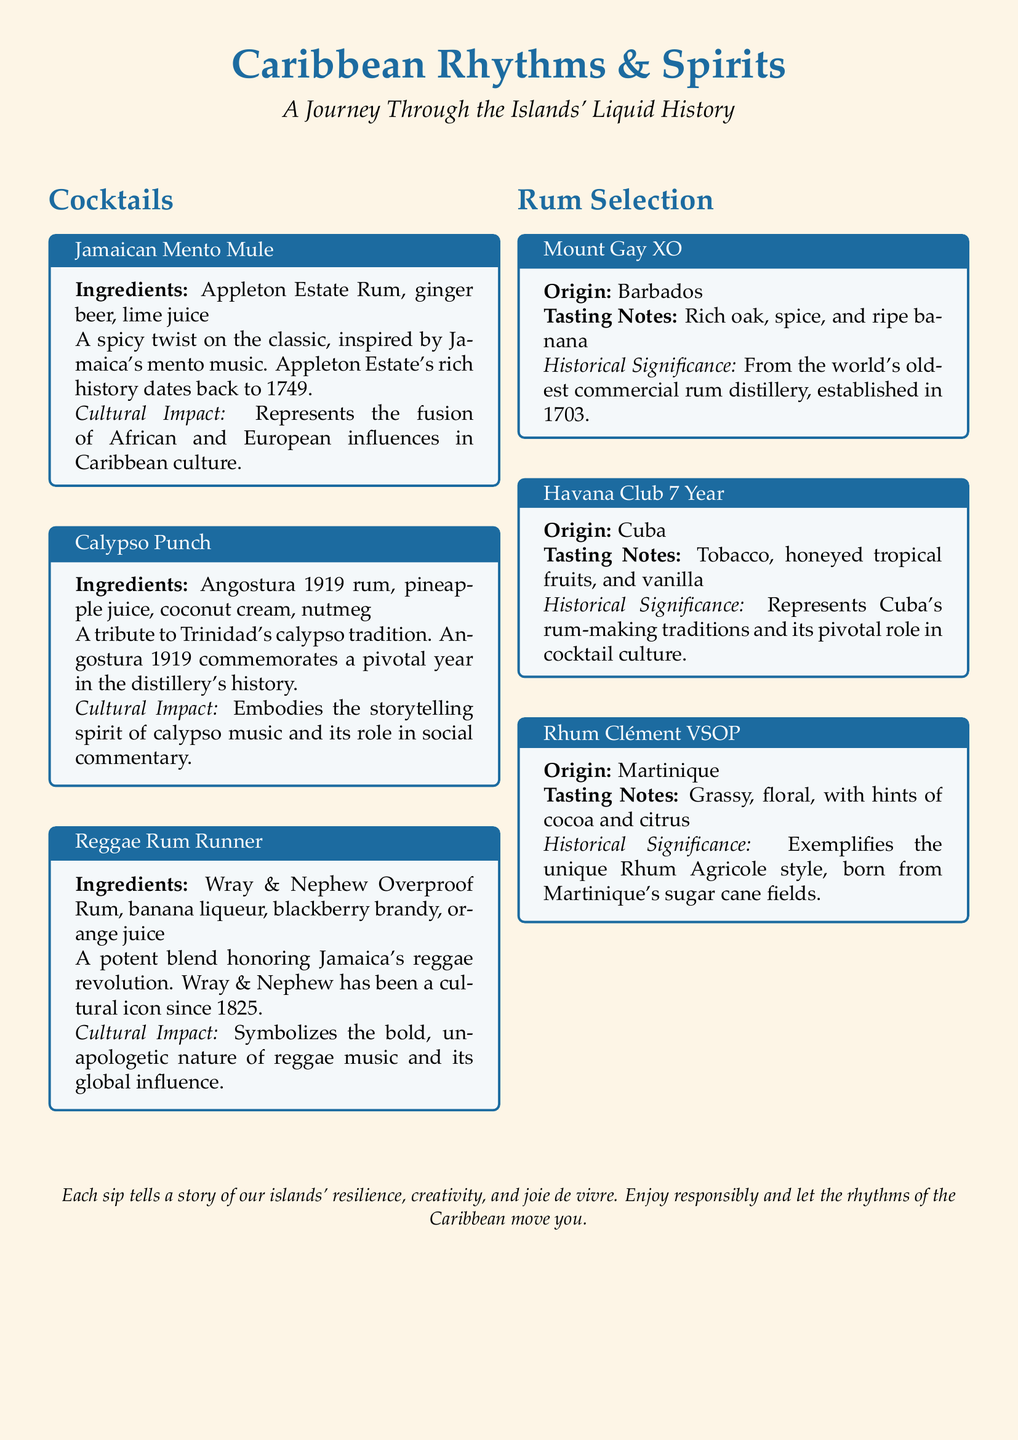What is the first cocktail listed? The first cocktail mentioned in the document is the Jamaican Mento Mule.
Answer: Jamaican Mento Mule What rum is used in Calypso Punch? Calypso Punch includes Angostura 1919 rum as one of its ingredients.
Answer: Angostura 1919 rum In what year was Appleton Estate Rum established? Appleton Estate Rum's history dates back to 1749.
Answer: 1749 What type of rum is Mount Gay XO? Mount Gay XO is a product from Barbados.
Answer: Barbados Which cocktail honors reggae music? The cocktail that honors reggae music is the Reggae Rum Runner.
Answer: Reggae Rum Runner What is the historical significance of Havana Club 7 Year? Havana Club 7 Year represents Cuba's rum-making traditions and its pivotal role in cocktail culture.
Answer: Cuba's rum-making traditions Which two ingredients are in the Jamaican Mento Mule? The ingredients in the Jamaican Mento Mule include ginger beer and lime juice.
Answer: ginger beer, lime juice What is the main cultural impact of Calypso Punch? Calypso Punch embodies the storytelling spirit of calypso music.
Answer: Storytelling spirit of calypso music What is the tasting note of Rhum Clément VSOP? Rhum Clément VSOP has grassy and floral tasting notes.
Answer: Grassy, floral 